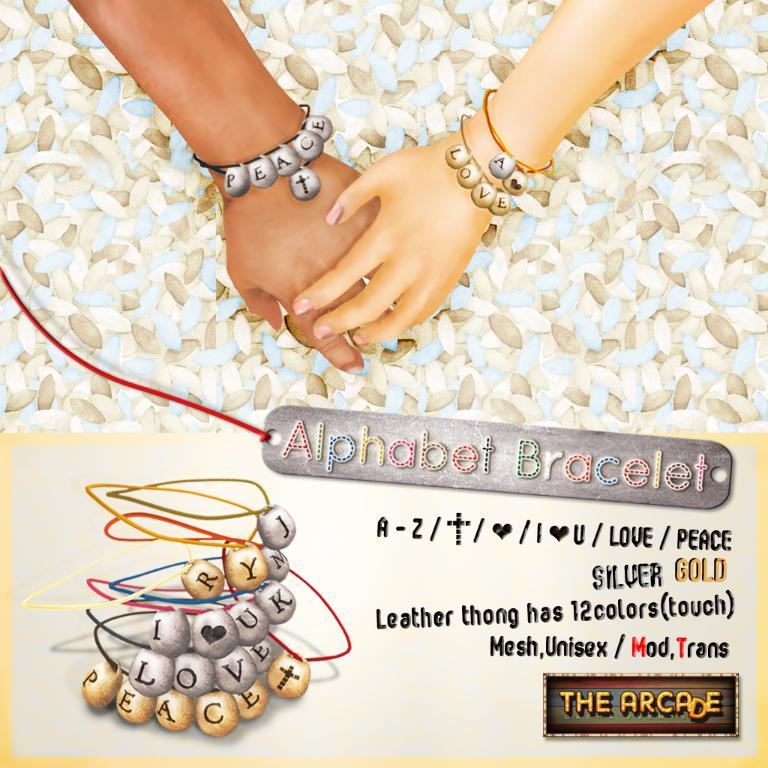What is the main subject of the image? The main subject of the image is two hands holding each other. What can be observed about the hands in the image? The hands are wearing bracelets. What is written on the bracelets? The bracelets have "peace" and "love" written on them. What else is present in the image related to the bracelets? There is a bunch of bracelets under the hands. Can you tell me how many corks are on the map in the image? There is no map or corks present in the image; it features two hands holding each other with bracelets. What type of bird is sitting on the wren in the image? There is no wren or bird present in the image. 